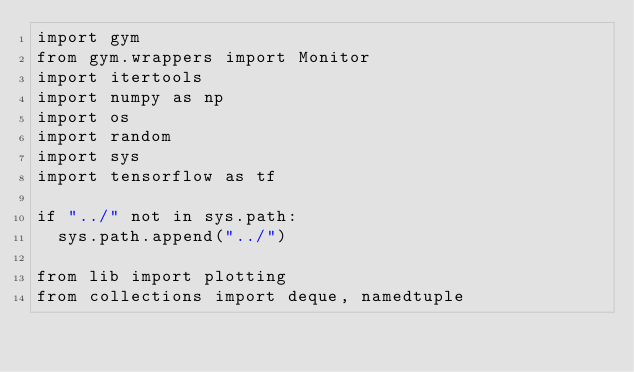<code> <loc_0><loc_0><loc_500><loc_500><_Python_>import gym
from gym.wrappers import Monitor
import itertools
import numpy as np
import os
import random
import sys
import tensorflow as tf

if "../" not in sys.path:
  sys.path.append("../")

from lib import plotting
from collections import deque, namedtuple
</code> 